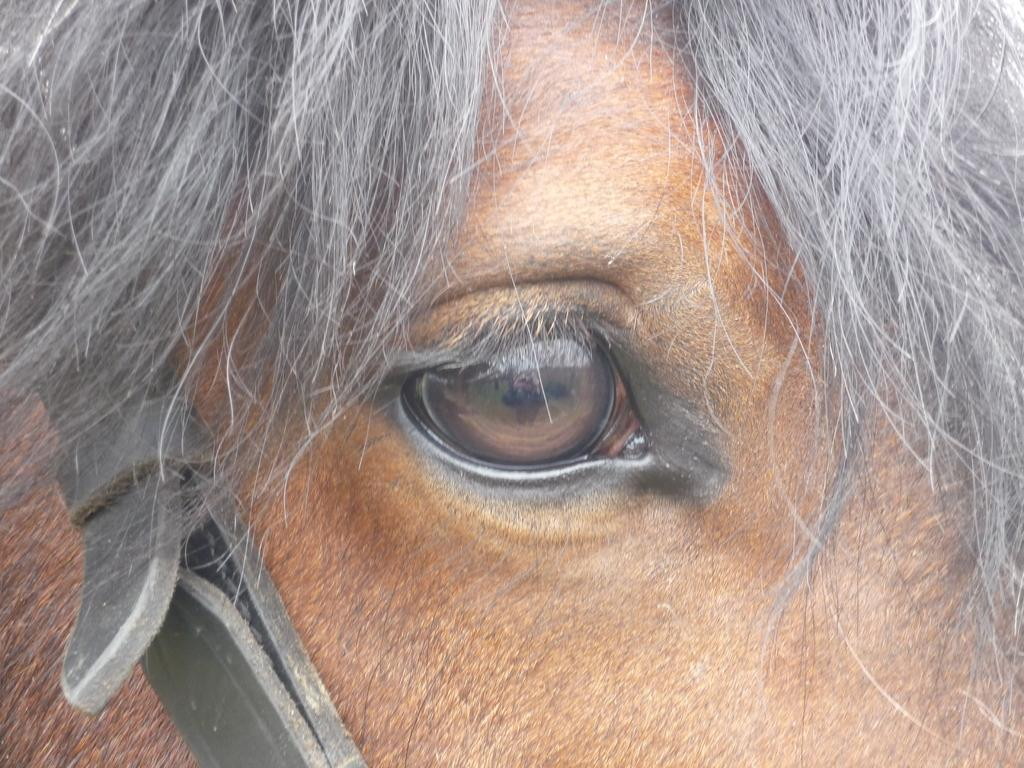What is the main subject of the image? The main subject of the image is the eye of a horse. What color is the horse's eye? The horse's eye is brown in color. What color is the horse's hair? The horse has black hair. What other object is visible in the image? There is a black belt visible in the image. What type of ink is being used to write on the alley in the image? There is no alley or ink present in the image; it features the eye of a horse and a black belt. How many hands are visible in the image? There are no hands visible in the image. 